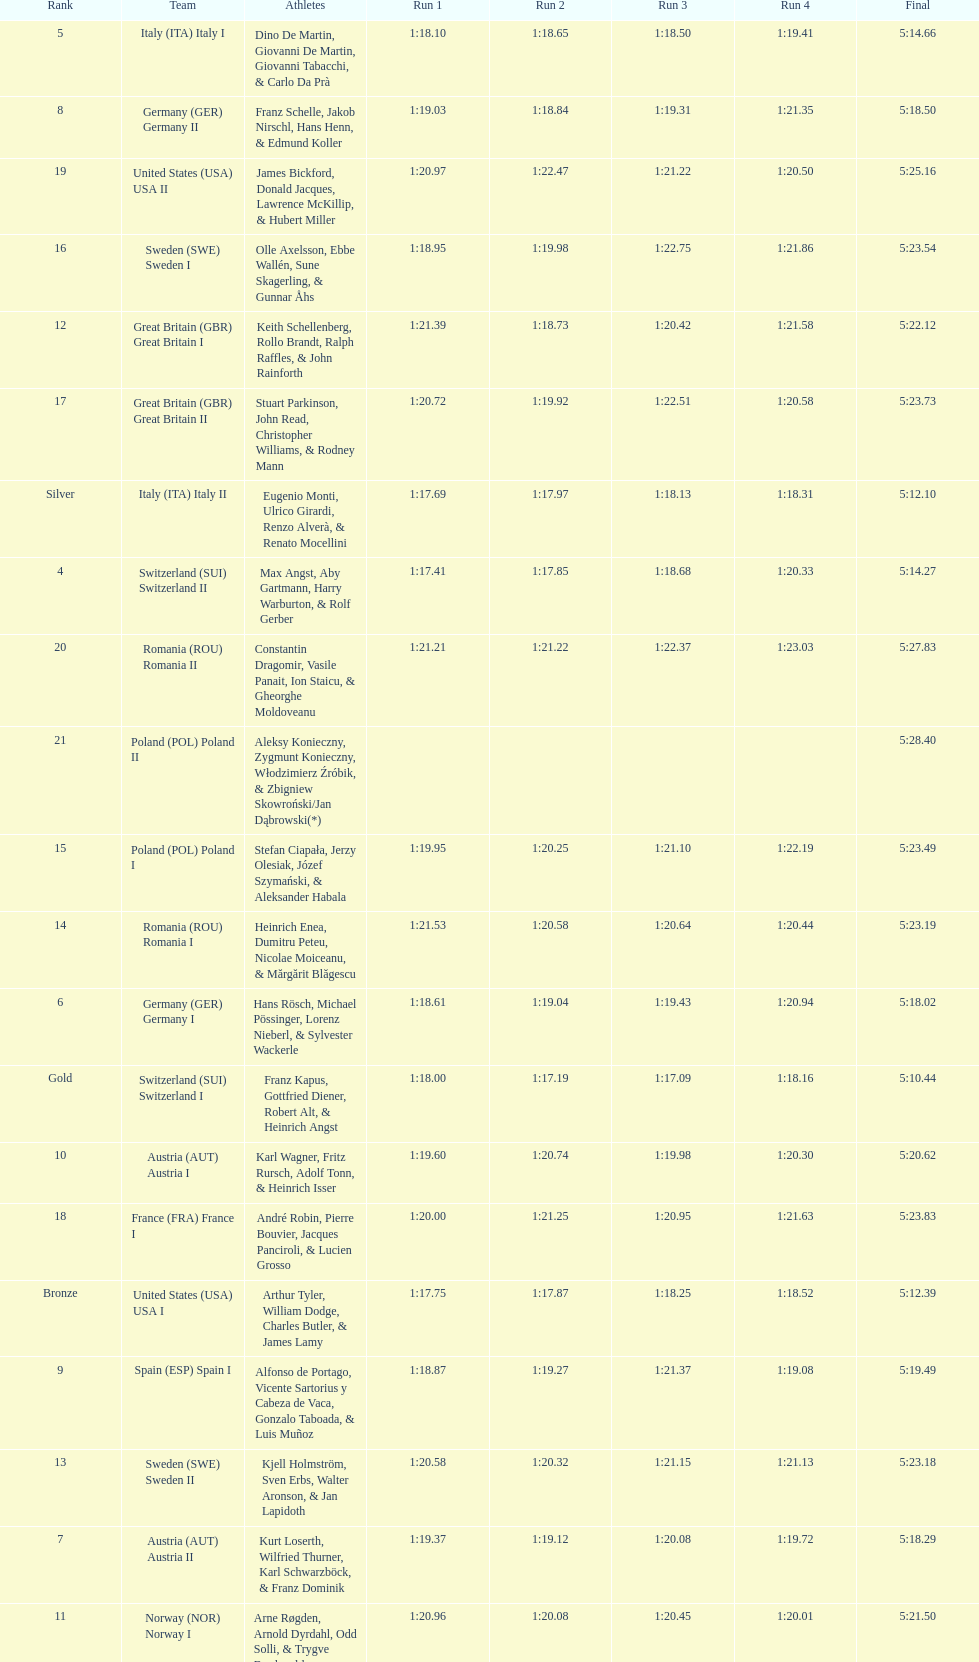Who placed the highest, italy or germany? Italy. 